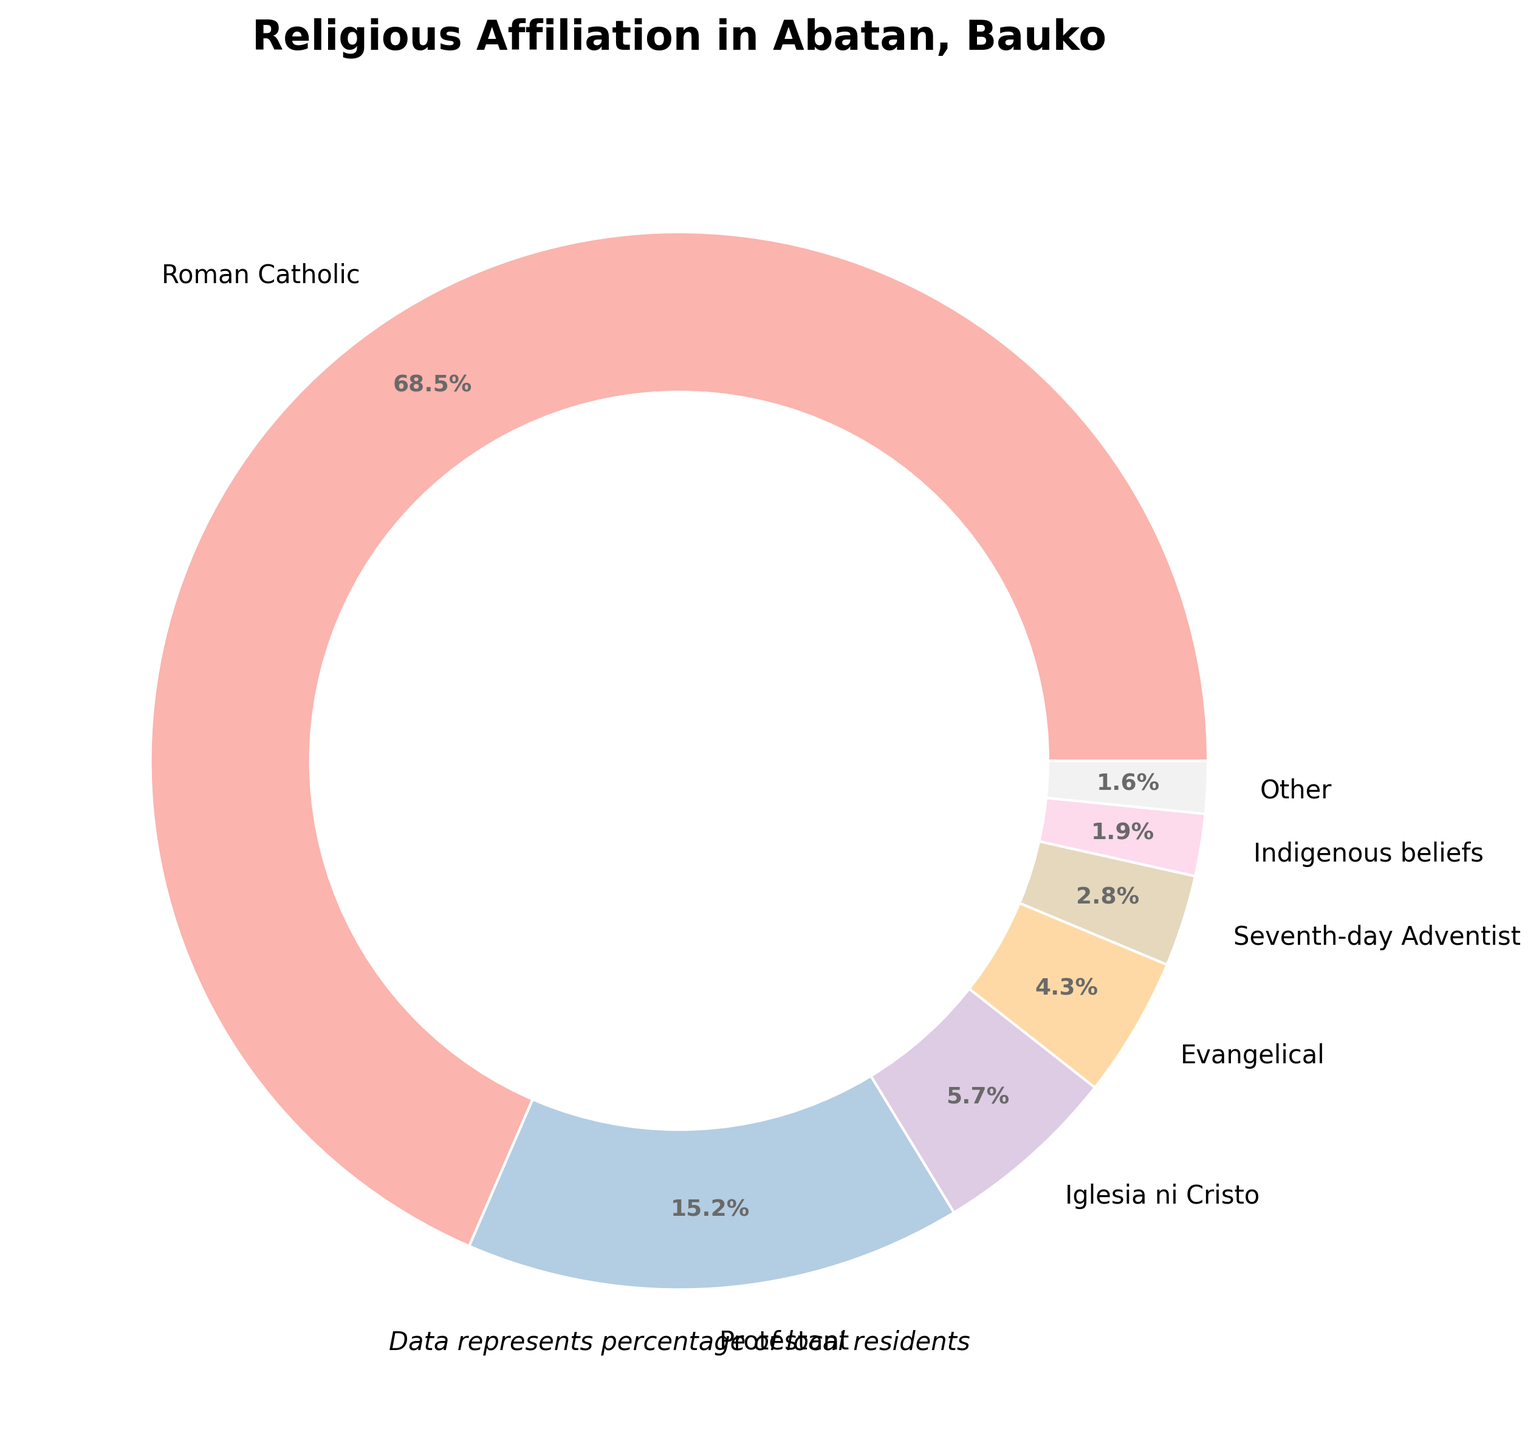Which religion has the highest percentage in Abatan, Bauko? The Roman Catholic denomination has the largest portion of the pie chart, indicating it has the highest percentage. The label shows 68.5%.
Answer: Roman Catholic What is the combined percentage of residents who belong to Protestant and Evangelical denominations? From the pie chart, the Protestant percentage is 15.2% and the Evangelical percentage is 4.3%. Adding them together: 15.2 + 4.3 = 19.5%
Answer: 19.5% Which religion has the smallest representation in Abatan, Bauko? The pie chart shows that the religion with the smallest percentage is 'No religion', labeled at 0.1%.
Answer: No religion How does the percentage of Iglesia ni Cristo compare to that of Seventh-day Adventist? Iglesia ni Cristo has 5.7% and Seventh-day Adventist has 2.8%, so Iglesia ni Cristo has a higher percentage.
Answer: Iglesia ni Cristo is higher What percentage of the population follows Indigenous beliefs? The pie chart lists Indigenous beliefs at 1.9%.
Answer: 1.9% Are there more Indigenous beliefs followers or Buddhists? Indigenous beliefs have 1.9% followers, while Buddhism has 0.4%. Indigenous beliefs have a higher percentage.
Answer: Indigenous beliefs What is the percentage of residents who follow religions categorized as "Other"? Small percentages are grouped into the "Other" category on the pie chart. The "Other" category is labeled with a certain percentage.
Answer: (Refer to the pie chart for the exact value; the answer may vary depending on code representation but assume it is clearly labeled.) What is the difference in the percentage of populations between Islam and Protestant? The pie chart shows Islam at 0.8% and Protestant at 15.2%. The difference is 15.2 - 0.8 = 14.4%.
Answer: 14.4% How many religions have a representation less than 1%? The pie chart shows 'Islam' at 0.8%, 'Buddhism' at 0.4%, 'Other Christian denominations' at 0.3%, and 'No religion' at 0.1%. That's four religions in total.
Answer: 4 